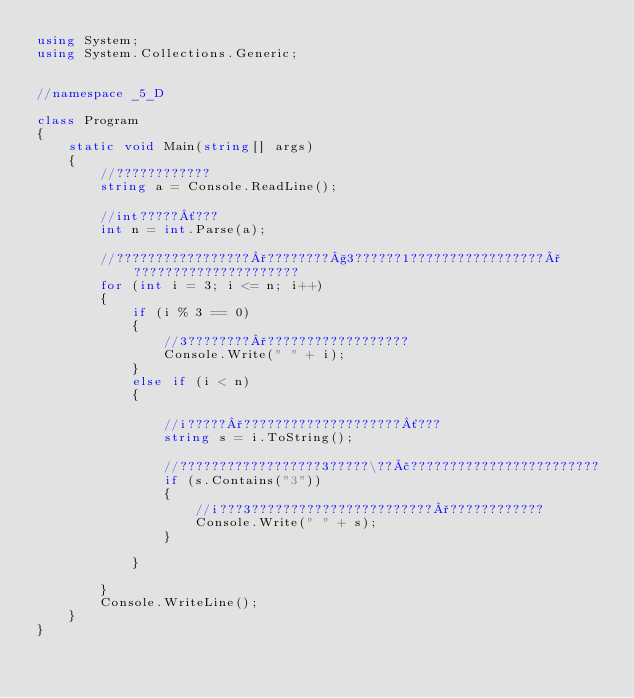Convert code to text. <code><loc_0><loc_0><loc_500><loc_500><_C#_>using System;
using System.Collections.Generic;


//namespace _5_D

class Program
{
    static void Main(string[] args)
    {
        //????????????
        string a = Console.ReadLine();

        //int?????´???
        int n = int.Parse(a);

        //?????????????????°????????§3??????1?????????????????°?????????????????????
        for (int i = 3; i <= n; i++)
        {
            if (i % 3 == 0)
            {
                //3????????°??????????????????
                Console.Write(" " + i);
            }
            else if (i < n)
            {

                //i?????°????????????????????´???
                string s = i.ToString();

                //??????????????????3?????\??£????????????????????????
                if (s.Contains("3"))
                {
                    //i???3???????????????????????°????????????
                    Console.Write(" " + s);
                }

            }

        }
        Console.WriteLine();
    }
}</code> 